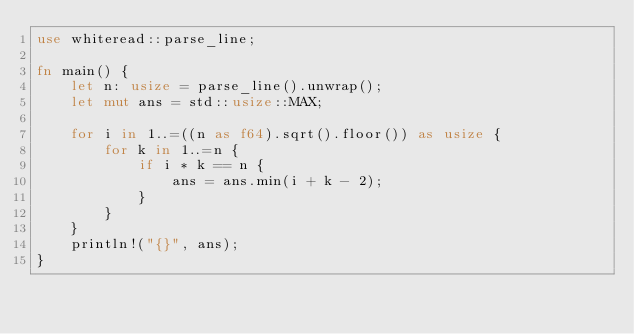Convert code to text. <code><loc_0><loc_0><loc_500><loc_500><_Rust_>use whiteread::parse_line;

fn main() {
    let n: usize = parse_line().unwrap();
    let mut ans = std::usize::MAX;

    for i in 1..=((n as f64).sqrt().floor()) as usize {
        for k in 1..=n {
            if i * k == n {
                ans = ans.min(i + k - 2);
            }
        }
    }
    println!("{}", ans);
}
</code> 